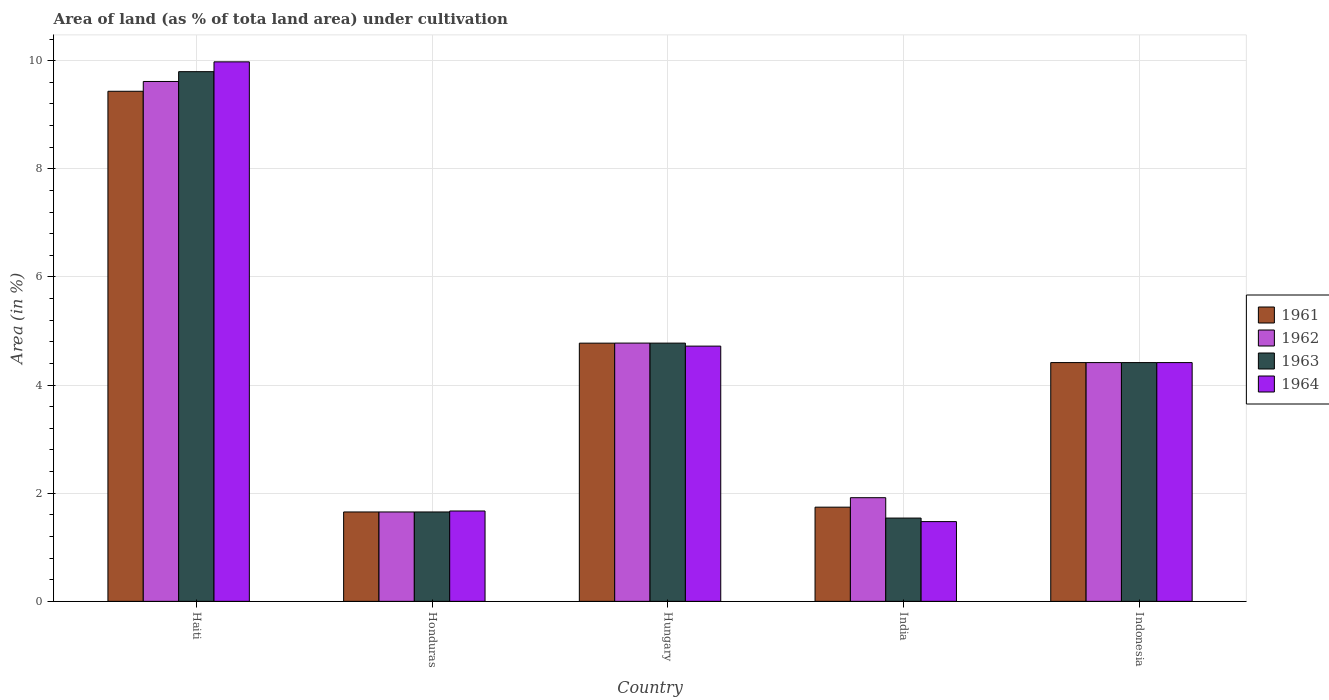Are the number of bars on each tick of the X-axis equal?
Provide a short and direct response. Yes. How many bars are there on the 1st tick from the left?
Provide a succinct answer. 4. How many bars are there on the 3rd tick from the right?
Give a very brief answer. 4. What is the label of the 3rd group of bars from the left?
Offer a very short reply. Hungary. What is the percentage of land under cultivation in 1963 in Hungary?
Your response must be concise. 4.78. Across all countries, what is the maximum percentage of land under cultivation in 1963?
Your response must be concise. 9.8. Across all countries, what is the minimum percentage of land under cultivation in 1962?
Keep it short and to the point. 1.65. In which country was the percentage of land under cultivation in 1964 maximum?
Your response must be concise. Haiti. In which country was the percentage of land under cultivation in 1963 minimum?
Provide a short and direct response. India. What is the total percentage of land under cultivation in 1963 in the graph?
Offer a very short reply. 22.18. What is the difference between the percentage of land under cultivation in 1961 in India and that in Indonesia?
Your response must be concise. -2.67. What is the difference between the percentage of land under cultivation in 1962 in Haiti and the percentage of land under cultivation in 1963 in India?
Provide a succinct answer. 8.07. What is the average percentage of land under cultivation in 1964 per country?
Make the answer very short. 4.45. What is the difference between the percentage of land under cultivation of/in 1961 and percentage of land under cultivation of/in 1964 in Honduras?
Your response must be concise. -0.02. In how many countries, is the percentage of land under cultivation in 1963 greater than 8.4 %?
Provide a short and direct response. 1. What is the ratio of the percentage of land under cultivation in 1961 in Haiti to that in Indonesia?
Your response must be concise. 2.14. What is the difference between the highest and the second highest percentage of land under cultivation in 1962?
Provide a short and direct response. 4.84. What is the difference between the highest and the lowest percentage of land under cultivation in 1961?
Your answer should be very brief. 7.78. In how many countries, is the percentage of land under cultivation in 1964 greater than the average percentage of land under cultivation in 1964 taken over all countries?
Offer a terse response. 2. Is it the case that in every country, the sum of the percentage of land under cultivation in 1962 and percentage of land under cultivation in 1964 is greater than the sum of percentage of land under cultivation in 1963 and percentage of land under cultivation in 1961?
Keep it short and to the point. No. What does the 3rd bar from the left in Indonesia represents?
Your answer should be compact. 1963. What does the 4th bar from the right in Honduras represents?
Keep it short and to the point. 1961. Are all the bars in the graph horizontal?
Offer a terse response. No. How many countries are there in the graph?
Your response must be concise. 5. Are the values on the major ticks of Y-axis written in scientific E-notation?
Your response must be concise. No. Does the graph contain grids?
Give a very brief answer. Yes. How many legend labels are there?
Ensure brevity in your answer.  4. What is the title of the graph?
Provide a succinct answer. Area of land (as % of tota land area) under cultivation. Does "1985" appear as one of the legend labels in the graph?
Give a very brief answer. No. What is the label or title of the Y-axis?
Provide a succinct answer. Area (in %). What is the Area (in %) in 1961 in Haiti?
Ensure brevity in your answer.  9.43. What is the Area (in %) in 1962 in Haiti?
Your response must be concise. 9.62. What is the Area (in %) in 1963 in Haiti?
Provide a succinct answer. 9.8. What is the Area (in %) of 1964 in Haiti?
Keep it short and to the point. 9.98. What is the Area (in %) in 1961 in Honduras?
Your answer should be compact. 1.65. What is the Area (in %) of 1962 in Honduras?
Make the answer very short. 1.65. What is the Area (in %) of 1963 in Honduras?
Your response must be concise. 1.65. What is the Area (in %) in 1964 in Honduras?
Give a very brief answer. 1.67. What is the Area (in %) in 1961 in Hungary?
Ensure brevity in your answer.  4.78. What is the Area (in %) in 1962 in Hungary?
Provide a succinct answer. 4.78. What is the Area (in %) in 1963 in Hungary?
Your response must be concise. 4.78. What is the Area (in %) of 1964 in Hungary?
Ensure brevity in your answer.  4.72. What is the Area (in %) of 1961 in India?
Ensure brevity in your answer.  1.74. What is the Area (in %) in 1962 in India?
Make the answer very short. 1.92. What is the Area (in %) in 1963 in India?
Your response must be concise. 1.54. What is the Area (in %) in 1964 in India?
Your response must be concise. 1.48. What is the Area (in %) of 1961 in Indonesia?
Your answer should be compact. 4.42. What is the Area (in %) in 1962 in Indonesia?
Your response must be concise. 4.42. What is the Area (in %) of 1963 in Indonesia?
Your response must be concise. 4.42. What is the Area (in %) in 1964 in Indonesia?
Keep it short and to the point. 4.42. Across all countries, what is the maximum Area (in %) of 1961?
Give a very brief answer. 9.43. Across all countries, what is the maximum Area (in %) in 1962?
Provide a short and direct response. 9.62. Across all countries, what is the maximum Area (in %) in 1963?
Keep it short and to the point. 9.8. Across all countries, what is the maximum Area (in %) in 1964?
Make the answer very short. 9.98. Across all countries, what is the minimum Area (in %) in 1961?
Provide a short and direct response. 1.65. Across all countries, what is the minimum Area (in %) of 1962?
Give a very brief answer. 1.65. Across all countries, what is the minimum Area (in %) in 1963?
Your response must be concise. 1.54. Across all countries, what is the minimum Area (in %) of 1964?
Your response must be concise. 1.48. What is the total Area (in %) in 1961 in the graph?
Offer a terse response. 22.02. What is the total Area (in %) in 1962 in the graph?
Make the answer very short. 22.38. What is the total Area (in %) of 1963 in the graph?
Provide a short and direct response. 22.18. What is the total Area (in %) of 1964 in the graph?
Give a very brief answer. 22.26. What is the difference between the Area (in %) in 1961 in Haiti and that in Honduras?
Make the answer very short. 7.78. What is the difference between the Area (in %) of 1962 in Haiti and that in Honduras?
Give a very brief answer. 7.96. What is the difference between the Area (in %) in 1963 in Haiti and that in Honduras?
Offer a very short reply. 8.14. What is the difference between the Area (in %) of 1964 in Haiti and that in Honduras?
Offer a terse response. 8.31. What is the difference between the Area (in %) of 1961 in Haiti and that in Hungary?
Make the answer very short. 4.66. What is the difference between the Area (in %) of 1962 in Haiti and that in Hungary?
Your response must be concise. 4.84. What is the difference between the Area (in %) in 1963 in Haiti and that in Hungary?
Ensure brevity in your answer.  5.02. What is the difference between the Area (in %) of 1964 in Haiti and that in Hungary?
Make the answer very short. 5.26. What is the difference between the Area (in %) in 1961 in Haiti and that in India?
Provide a short and direct response. 7.69. What is the difference between the Area (in %) of 1962 in Haiti and that in India?
Keep it short and to the point. 7.7. What is the difference between the Area (in %) of 1963 in Haiti and that in India?
Give a very brief answer. 8.26. What is the difference between the Area (in %) of 1964 in Haiti and that in India?
Offer a terse response. 8.5. What is the difference between the Area (in %) of 1961 in Haiti and that in Indonesia?
Your answer should be compact. 5.02. What is the difference between the Area (in %) in 1962 in Haiti and that in Indonesia?
Your answer should be very brief. 5.2. What is the difference between the Area (in %) of 1963 in Haiti and that in Indonesia?
Provide a short and direct response. 5.38. What is the difference between the Area (in %) of 1964 in Haiti and that in Indonesia?
Your answer should be compact. 5.56. What is the difference between the Area (in %) of 1961 in Honduras and that in Hungary?
Keep it short and to the point. -3.12. What is the difference between the Area (in %) in 1962 in Honduras and that in Hungary?
Offer a terse response. -3.12. What is the difference between the Area (in %) in 1963 in Honduras and that in Hungary?
Your answer should be compact. -3.12. What is the difference between the Area (in %) of 1964 in Honduras and that in Hungary?
Provide a succinct answer. -3.05. What is the difference between the Area (in %) of 1961 in Honduras and that in India?
Ensure brevity in your answer.  -0.09. What is the difference between the Area (in %) in 1962 in Honduras and that in India?
Your answer should be very brief. -0.26. What is the difference between the Area (in %) in 1963 in Honduras and that in India?
Offer a very short reply. 0.11. What is the difference between the Area (in %) of 1964 in Honduras and that in India?
Offer a very short reply. 0.2. What is the difference between the Area (in %) in 1961 in Honduras and that in Indonesia?
Offer a terse response. -2.76. What is the difference between the Area (in %) of 1962 in Honduras and that in Indonesia?
Provide a short and direct response. -2.76. What is the difference between the Area (in %) in 1963 in Honduras and that in Indonesia?
Offer a very short reply. -2.76. What is the difference between the Area (in %) of 1964 in Honduras and that in Indonesia?
Provide a succinct answer. -2.74. What is the difference between the Area (in %) of 1961 in Hungary and that in India?
Offer a terse response. 3.03. What is the difference between the Area (in %) in 1962 in Hungary and that in India?
Your answer should be compact. 2.86. What is the difference between the Area (in %) in 1963 in Hungary and that in India?
Give a very brief answer. 3.24. What is the difference between the Area (in %) in 1964 in Hungary and that in India?
Provide a short and direct response. 3.25. What is the difference between the Area (in %) in 1961 in Hungary and that in Indonesia?
Make the answer very short. 0.36. What is the difference between the Area (in %) of 1962 in Hungary and that in Indonesia?
Make the answer very short. 0.36. What is the difference between the Area (in %) in 1963 in Hungary and that in Indonesia?
Offer a very short reply. 0.36. What is the difference between the Area (in %) in 1964 in Hungary and that in Indonesia?
Offer a terse response. 0.3. What is the difference between the Area (in %) in 1961 in India and that in Indonesia?
Offer a very short reply. -2.67. What is the difference between the Area (in %) in 1962 in India and that in Indonesia?
Give a very brief answer. -2.5. What is the difference between the Area (in %) in 1963 in India and that in Indonesia?
Make the answer very short. -2.88. What is the difference between the Area (in %) in 1964 in India and that in Indonesia?
Your answer should be compact. -2.94. What is the difference between the Area (in %) in 1961 in Haiti and the Area (in %) in 1962 in Honduras?
Your answer should be compact. 7.78. What is the difference between the Area (in %) in 1961 in Haiti and the Area (in %) in 1963 in Honduras?
Provide a succinct answer. 7.78. What is the difference between the Area (in %) of 1961 in Haiti and the Area (in %) of 1964 in Honduras?
Provide a short and direct response. 7.76. What is the difference between the Area (in %) in 1962 in Haiti and the Area (in %) in 1963 in Honduras?
Your response must be concise. 7.96. What is the difference between the Area (in %) in 1962 in Haiti and the Area (in %) in 1964 in Honduras?
Your response must be concise. 7.94. What is the difference between the Area (in %) of 1963 in Haiti and the Area (in %) of 1964 in Honduras?
Your answer should be compact. 8.13. What is the difference between the Area (in %) of 1961 in Haiti and the Area (in %) of 1962 in Hungary?
Provide a short and direct response. 4.66. What is the difference between the Area (in %) of 1961 in Haiti and the Area (in %) of 1963 in Hungary?
Make the answer very short. 4.66. What is the difference between the Area (in %) of 1961 in Haiti and the Area (in %) of 1964 in Hungary?
Your response must be concise. 4.71. What is the difference between the Area (in %) in 1962 in Haiti and the Area (in %) in 1963 in Hungary?
Offer a very short reply. 4.84. What is the difference between the Area (in %) in 1962 in Haiti and the Area (in %) in 1964 in Hungary?
Make the answer very short. 4.89. What is the difference between the Area (in %) in 1963 in Haiti and the Area (in %) in 1964 in Hungary?
Ensure brevity in your answer.  5.08. What is the difference between the Area (in %) of 1961 in Haiti and the Area (in %) of 1962 in India?
Your answer should be very brief. 7.52. What is the difference between the Area (in %) in 1961 in Haiti and the Area (in %) in 1963 in India?
Your response must be concise. 7.89. What is the difference between the Area (in %) of 1961 in Haiti and the Area (in %) of 1964 in India?
Give a very brief answer. 7.96. What is the difference between the Area (in %) of 1962 in Haiti and the Area (in %) of 1963 in India?
Ensure brevity in your answer.  8.07. What is the difference between the Area (in %) of 1962 in Haiti and the Area (in %) of 1964 in India?
Provide a short and direct response. 8.14. What is the difference between the Area (in %) in 1963 in Haiti and the Area (in %) in 1964 in India?
Offer a very short reply. 8.32. What is the difference between the Area (in %) of 1961 in Haiti and the Area (in %) of 1962 in Indonesia?
Keep it short and to the point. 5.02. What is the difference between the Area (in %) in 1961 in Haiti and the Area (in %) in 1963 in Indonesia?
Your answer should be very brief. 5.02. What is the difference between the Area (in %) in 1961 in Haiti and the Area (in %) in 1964 in Indonesia?
Your answer should be very brief. 5.02. What is the difference between the Area (in %) in 1962 in Haiti and the Area (in %) in 1963 in Indonesia?
Your answer should be compact. 5.2. What is the difference between the Area (in %) in 1962 in Haiti and the Area (in %) in 1964 in Indonesia?
Provide a succinct answer. 5.2. What is the difference between the Area (in %) of 1963 in Haiti and the Area (in %) of 1964 in Indonesia?
Provide a succinct answer. 5.38. What is the difference between the Area (in %) of 1961 in Honduras and the Area (in %) of 1962 in Hungary?
Provide a short and direct response. -3.12. What is the difference between the Area (in %) of 1961 in Honduras and the Area (in %) of 1963 in Hungary?
Keep it short and to the point. -3.12. What is the difference between the Area (in %) in 1961 in Honduras and the Area (in %) in 1964 in Hungary?
Your response must be concise. -3.07. What is the difference between the Area (in %) in 1962 in Honduras and the Area (in %) in 1963 in Hungary?
Ensure brevity in your answer.  -3.12. What is the difference between the Area (in %) of 1962 in Honduras and the Area (in %) of 1964 in Hungary?
Provide a succinct answer. -3.07. What is the difference between the Area (in %) in 1963 in Honduras and the Area (in %) in 1964 in Hungary?
Offer a terse response. -3.07. What is the difference between the Area (in %) of 1961 in Honduras and the Area (in %) of 1962 in India?
Your answer should be very brief. -0.26. What is the difference between the Area (in %) of 1961 in Honduras and the Area (in %) of 1963 in India?
Your answer should be compact. 0.11. What is the difference between the Area (in %) of 1961 in Honduras and the Area (in %) of 1964 in India?
Make the answer very short. 0.18. What is the difference between the Area (in %) of 1962 in Honduras and the Area (in %) of 1963 in India?
Keep it short and to the point. 0.11. What is the difference between the Area (in %) of 1962 in Honduras and the Area (in %) of 1964 in India?
Ensure brevity in your answer.  0.18. What is the difference between the Area (in %) of 1963 in Honduras and the Area (in %) of 1964 in India?
Your response must be concise. 0.18. What is the difference between the Area (in %) in 1961 in Honduras and the Area (in %) in 1962 in Indonesia?
Offer a very short reply. -2.76. What is the difference between the Area (in %) of 1961 in Honduras and the Area (in %) of 1963 in Indonesia?
Make the answer very short. -2.76. What is the difference between the Area (in %) in 1961 in Honduras and the Area (in %) in 1964 in Indonesia?
Provide a succinct answer. -2.76. What is the difference between the Area (in %) of 1962 in Honduras and the Area (in %) of 1963 in Indonesia?
Provide a short and direct response. -2.76. What is the difference between the Area (in %) of 1962 in Honduras and the Area (in %) of 1964 in Indonesia?
Your answer should be very brief. -2.76. What is the difference between the Area (in %) of 1963 in Honduras and the Area (in %) of 1964 in Indonesia?
Your answer should be compact. -2.76. What is the difference between the Area (in %) in 1961 in Hungary and the Area (in %) in 1962 in India?
Ensure brevity in your answer.  2.86. What is the difference between the Area (in %) in 1961 in Hungary and the Area (in %) in 1963 in India?
Your response must be concise. 3.24. What is the difference between the Area (in %) of 1961 in Hungary and the Area (in %) of 1964 in India?
Your answer should be very brief. 3.3. What is the difference between the Area (in %) in 1962 in Hungary and the Area (in %) in 1963 in India?
Offer a very short reply. 3.24. What is the difference between the Area (in %) in 1962 in Hungary and the Area (in %) in 1964 in India?
Offer a terse response. 3.3. What is the difference between the Area (in %) in 1963 in Hungary and the Area (in %) in 1964 in India?
Make the answer very short. 3.3. What is the difference between the Area (in %) of 1961 in Hungary and the Area (in %) of 1962 in Indonesia?
Provide a succinct answer. 0.36. What is the difference between the Area (in %) of 1961 in Hungary and the Area (in %) of 1963 in Indonesia?
Offer a very short reply. 0.36. What is the difference between the Area (in %) in 1961 in Hungary and the Area (in %) in 1964 in Indonesia?
Offer a terse response. 0.36. What is the difference between the Area (in %) of 1962 in Hungary and the Area (in %) of 1963 in Indonesia?
Provide a succinct answer. 0.36. What is the difference between the Area (in %) of 1962 in Hungary and the Area (in %) of 1964 in Indonesia?
Provide a succinct answer. 0.36. What is the difference between the Area (in %) of 1963 in Hungary and the Area (in %) of 1964 in Indonesia?
Your answer should be very brief. 0.36. What is the difference between the Area (in %) in 1961 in India and the Area (in %) in 1962 in Indonesia?
Make the answer very short. -2.67. What is the difference between the Area (in %) in 1961 in India and the Area (in %) in 1963 in Indonesia?
Your answer should be very brief. -2.67. What is the difference between the Area (in %) in 1961 in India and the Area (in %) in 1964 in Indonesia?
Keep it short and to the point. -2.67. What is the difference between the Area (in %) in 1962 in India and the Area (in %) in 1963 in Indonesia?
Make the answer very short. -2.5. What is the difference between the Area (in %) in 1962 in India and the Area (in %) in 1964 in Indonesia?
Ensure brevity in your answer.  -2.5. What is the difference between the Area (in %) of 1963 in India and the Area (in %) of 1964 in Indonesia?
Ensure brevity in your answer.  -2.88. What is the average Area (in %) of 1961 per country?
Ensure brevity in your answer.  4.4. What is the average Area (in %) in 1962 per country?
Provide a short and direct response. 4.48. What is the average Area (in %) in 1963 per country?
Ensure brevity in your answer.  4.44. What is the average Area (in %) of 1964 per country?
Make the answer very short. 4.45. What is the difference between the Area (in %) in 1961 and Area (in %) in 1962 in Haiti?
Ensure brevity in your answer.  -0.18. What is the difference between the Area (in %) of 1961 and Area (in %) of 1963 in Haiti?
Keep it short and to the point. -0.36. What is the difference between the Area (in %) in 1961 and Area (in %) in 1964 in Haiti?
Offer a very short reply. -0.54. What is the difference between the Area (in %) in 1962 and Area (in %) in 1963 in Haiti?
Provide a short and direct response. -0.18. What is the difference between the Area (in %) of 1962 and Area (in %) of 1964 in Haiti?
Your response must be concise. -0.36. What is the difference between the Area (in %) of 1963 and Area (in %) of 1964 in Haiti?
Provide a short and direct response. -0.18. What is the difference between the Area (in %) in 1961 and Area (in %) in 1962 in Honduras?
Provide a succinct answer. 0. What is the difference between the Area (in %) of 1961 and Area (in %) of 1963 in Honduras?
Your answer should be very brief. 0. What is the difference between the Area (in %) of 1961 and Area (in %) of 1964 in Honduras?
Make the answer very short. -0.02. What is the difference between the Area (in %) of 1962 and Area (in %) of 1964 in Honduras?
Make the answer very short. -0.02. What is the difference between the Area (in %) in 1963 and Area (in %) in 1964 in Honduras?
Offer a terse response. -0.02. What is the difference between the Area (in %) of 1961 and Area (in %) of 1962 in Hungary?
Your answer should be very brief. -0. What is the difference between the Area (in %) of 1961 and Area (in %) of 1963 in Hungary?
Give a very brief answer. -0. What is the difference between the Area (in %) of 1961 and Area (in %) of 1964 in Hungary?
Your answer should be very brief. 0.06. What is the difference between the Area (in %) of 1962 and Area (in %) of 1964 in Hungary?
Make the answer very short. 0.06. What is the difference between the Area (in %) in 1963 and Area (in %) in 1964 in Hungary?
Keep it short and to the point. 0.06. What is the difference between the Area (in %) of 1961 and Area (in %) of 1962 in India?
Ensure brevity in your answer.  -0.17. What is the difference between the Area (in %) in 1961 and Area (in %) in 1963 in India?
Your response must be concise. 0.2. What is the difference between the Area (in %) in 1961 and Area (in %) in 1964 in India?
Offer a terse response. 0.27. What is the difference between the Area (in %) in 1962 and Area (in %) in 1963 in India?
Your answer should be compact. 0.38. What is the difference between the Area (in %) in 1962 and Area (in %) in 1964 in India?
Your response must be concise. 0.44. What is the difference between the Area (in %) of 1963 and Area (in %) of 1964 in India?
Ensure brevity in your answer.  0.07. What is the difference between the Area (in %) of 1961 and Area (in %) of 1963 in Indonesia?
Make the answer very short. 0. What is the difference between the Area (in %) in 1961 and Area (in %) in 1964 in Indonesia?
Offer a terse response. 0. What is the difference between the Area (in %) in 1962 and Area (in %) in 1963 in Indonesia?
Ensure brevity in your answer.  0. What is the difference between the Area (in %) in 1963 and Area (in %) in 1964 in Indonesia?
Your answer should be very brief. 0. What is the ratio of the Area (in %) of 1961 in Haiti to that in Honduras?
Your answer should be very brief. 5.71. What is the ratio of the Area (in %) in 1962 in Haiti to that in Honduras?
Offer a terse response. 5.82. What is the ratio of the Area (in %) of 1963 in Haiti to that in Honduras?
Provide a succinct answer. 5.93. What is the ratio of the Area (in %) of 1964 in Haiti to that in Honduras?
Ensure brevity in your answer.  5.97. What is the ratio of the Area (in %) in 1961 in Haiti to that in Hungary?
Your answer should be very brief. 1.98. What is the ratio of the Area (in %) of 1962 in Haiti to that in Hungary?
Ensure brevity in your answer.  2.01. What is the ratio of the Area (in %) of 1963 in Haiti to that in Hungary?
Give a very brief answer. 2.05. What is the ratio of the Area (in %) of 1964 in Haiti to that in Hungary?
Ensure brevity in your answer.  2.11. What is the ratio of the Area (in %) of 1961 in Haiti to that in India?
Keep it short and to the point. 5.41. What is the ratio of the Area (in %) in 1962 in Haiti to that in India?
Offer a terse response. 5.02. What is the ratio of the Area (in %) in 1963 in Haiti to that in India?
Provide a short and direct response. 6.36. What is the ratio of the Area (in %) in 1964 in Haiti to that in India?
Ensure brevity in your answer.  6.76. What is the ratio of the Area (in %) in 1961 in Haiti to that in Indonesia?
Your answer should be compact. 2.14. What is the ratio of the Area (in %) of 1962 in Haiti to that in Indonesia?
Provide a succinct answer. 2.18. What is the ratio of the Area (in %) of 1963 in Haiti to that in Indonesia?
Keep it short and to the point. 2.22. What is the ratio of the Area (in %) in 1964 in Haiti to that in Indonesia?
Your answer should be compact. 2.26. What is the ratio of the Area (in %) of 1961 in Honduras to that in Hungary?
Ensure brevity in your answer.  0.35. What is the ratio of the Area (in %) in 1962 in Honduras to that in Hungary?
Offer a very short reply. 0.35. What is the ratio of the Area (in %) of 1963 in Honduras to that in Hungary?
Offer a very short reply. 0.35. What is the ratio of the Area (in %) in 1964 in Honduras to that in Hungary?
Provide a succinct answer. 0.35. What is the ratio of the Area (in %) of 1961 in Honduras to that in India?
Keep it short and to the point. 0.95. What is the ratio of the Area (in %) of 1962 in Honduras to that in India?
Provide a succinct answer. 0.86. What is the ratio of the Area (in %) of 1963 in Honduras to that in India?
Provide a succinct answer. 1.07. What is the ratio of the Area (in %) in 1964 in Honduras to that in India?
Offer a terse response. 1.13. What is the ratio of the Area (in %) of 1961 in Honduras to that in Indonesia?
Ensure brevity in your answer.  0.37. What is the ratio of the Area (in %) of 1962 in Honduras to that in Indonesia?
Provide a short and direct response. 0.37. What is the ratio of the Area (in %) of 1963 in Honduras to that in Indonesia?
Give a very brief answer. 0.37. What is the ratio of the Area (in %) in 1964 in Honduras to that in Indonesia?
Give a very brief answer. 0.38. What is the ratio of the Area (in %) of 1961 in Hungary to that in India?
Your response must be concise. 2.74. What is the ratio of the Area (in %) of 1962 in Hungary to that in India?
Make the answer very short. 2.49. What is the ratio of the Area (in %) in 1963 in Hungary to that in India?
Provide a succinct answer. 3.1. What is the ratio of the Area (in %) in 1961 in Hungary to that in Indonesia?
Offer a very short reply. 1.08. What is the ratio of the Area (in %) of 1962 in Hungary to that in Indonesia?
Ensure brevity in your answer.  1.08. What is the ratio of the Area (in %) in 1963 in Hungary to that in Indonesia?
Make the answer very short. 1.08. What is the ratio of the Area (in %) of 1964 in Hungary to that in Indonesia?
Make the answer very short. 1.07. What is the ratio of the Area (in %) of 1961 in India to that in Indonesia?
Offer a terse response. 0.39. What is the ratio of the Area (in %) in 1962 in India to that in Indonesia?
Your response must be concise. 0.43. What is the ratio of the Area (in %) of 1963 in India to that in Indonesia?
Your answer should be compact. 0.35. What is the ratio of the Area (in %) of 1964 in India to that in Indonesia?
Your answer should be very brief. 0.33. What is the difference between the highest and the second highest Area (in %) of 1961?
Give a very brief answer. 4.66. What is the difference between the highest and the second highest Area (in %) in 1962?
Make the answer very short. 4.84. What is the difference between the highest and the second highest Area (in %) of 1963?
Provide a succinct answer. 5.02. What is the difference between the highest and the second highest Area (in %) of 1964?
Your answer should be compact. 5.26. What is the difference between the highest and the lowest Area (in %) in 1961?
Your response must be concise. 7.78. What is the difference between the highest and the lowest Area (in %) in 1962?
Provide a succinct answer. 7.96. What is the difference between the highest and the lowest Area (in %) in 1963?
Your answer should be compact. 8.26. What is the difference between the highest and the lowest Area (in %) in 1964?
Offer a terse response. 8.5. 